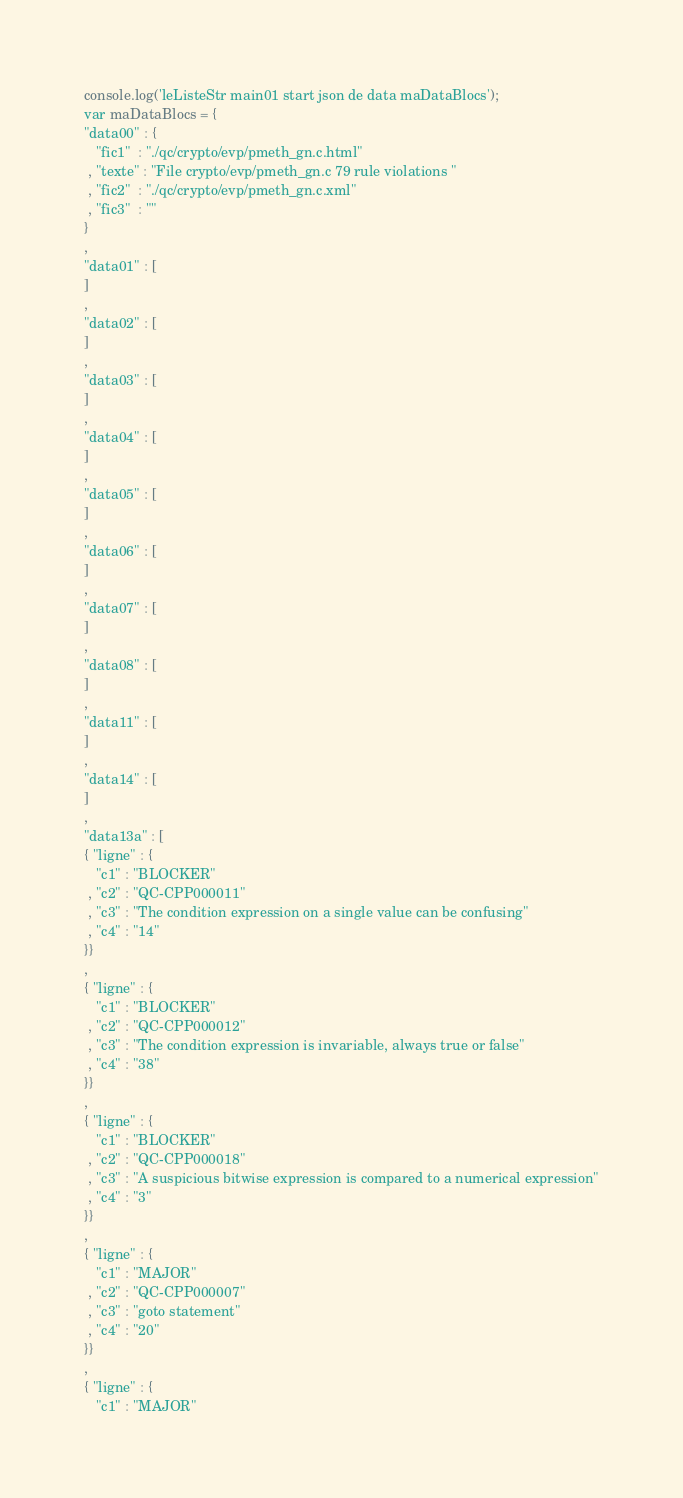<code> <loc_0><loc_0><loc_500><loc_500><_JavaScript_>console.log('leListeStr main01 start json de data maDataBlocs');
var maDataBlocs = {
"data00" : {
   "fic1"  : "./qc/crypto/evp/pmeth_gn.c.html" 
 , "texte" : "File crypto/evp/pmeth_gn.c 79 rule violations " 
 , "fic2"  : "./qc/crypto/evp/pmeth_gn.c.xml" 
 , "fic3"  : "" 
}
, 
"data01" : [
]
, 
"data02" : [
]
, 
"data03" : [
] 
, 
"data04" : [
]
, 
"data05" : [
]
, 
"data06" : [
]
, 
"data07" : [
]
, 
"data08" : [
]
, 
"data11" : [
]
, 
"data14" : [
]
, 
"data13a" : [
{ "ligne" : {
   "c1" : "BLOCKER"
 , "c2" : "QC-CPP000011"
 , "c3" : "The condition expression on a single value can be confusing"
 , "c4" : "14"
}}
,
{ "ligne" : {
   "c1" : "BLOCKER"
 , "c2" : "QC-CPP000012"
 , "c3" : "The condition expression is invariable, always true or false"
 , "c4" : "38"
}}
,
{ "ligne" : {
   "c1" : "BLOCKER"
 , "c2" : "QC-CPP000018"
 , "c3" : "A suspicious bitwise expression is compared to a numerical expression"
 , "c4" : "3"
}}
,
{ "ligne" : {
   "c1" : "MAJOR"
 , "c2" : "QC-CPP000007"
 , "c3" : "goto statement"
 , "c4" : "20"
}}
,
{ "ligne" : {
   "c1" : "MAJOR"</code> 